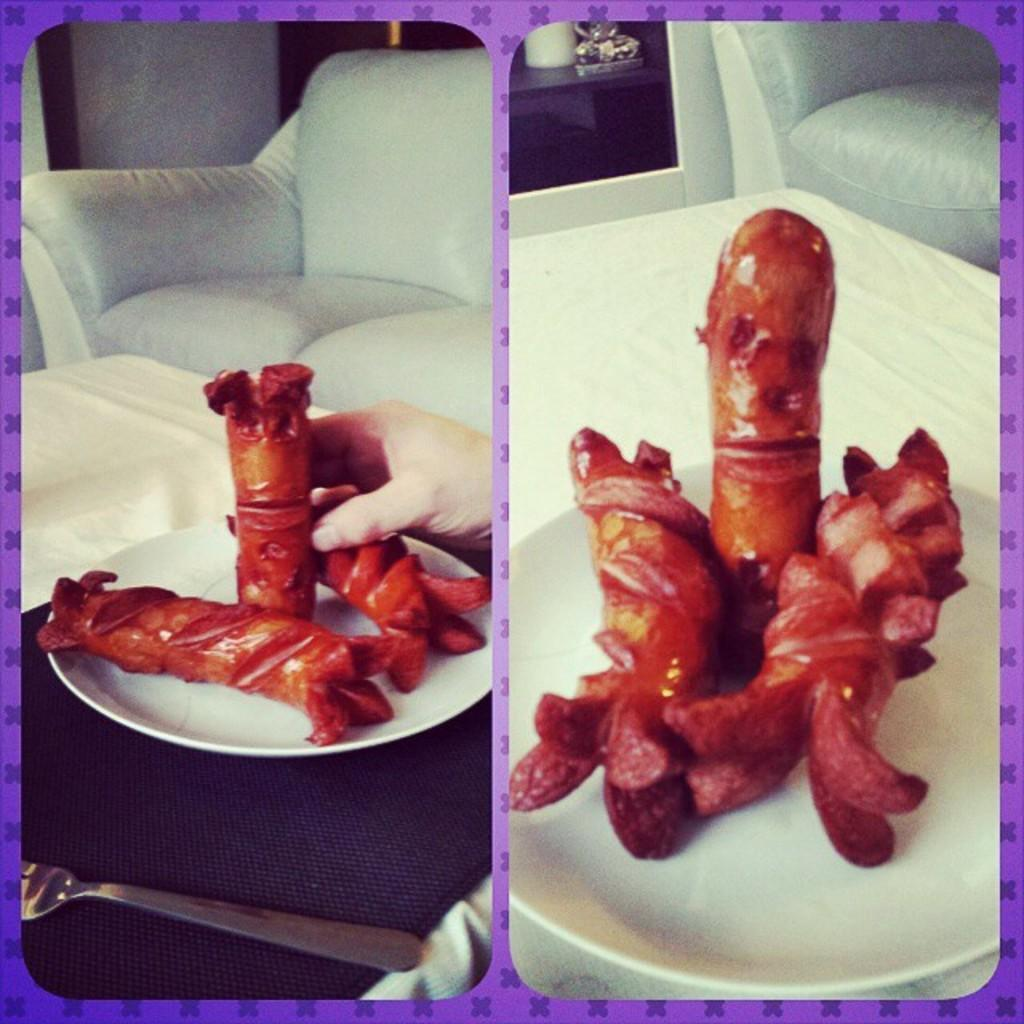What type of artwork is featured in the image? The image contains collage photos. What objects can be seen in the collage photos? In the collage photos, there is a plate with food items. What utensil is visible in the image? There is a fork visible in the image. What type of furniture is present in the image? There is a sofa in the image. What type of engine is visible in the image? There is no engine present in the image; it features collage photos with a plate, food items, and a fork. What type of stick can be seen in the image? There is no stick present in the image. 